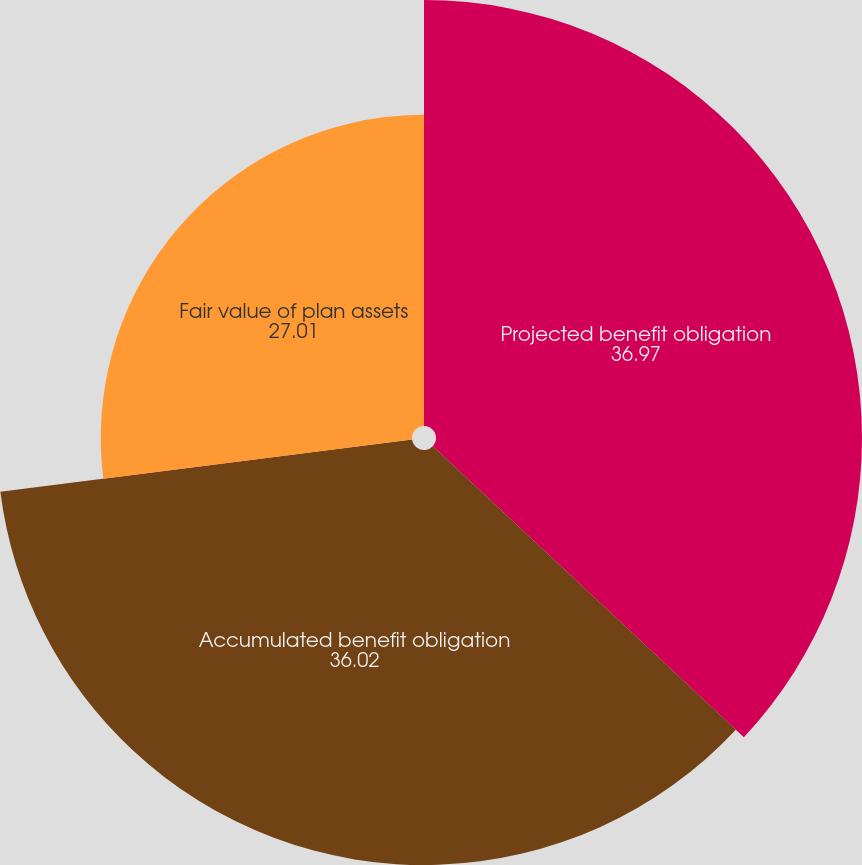<chart> <loc_0><loc_0><loc_500><loc_500><pie_chart><fcel>Projected benefit obligation<fcel>Accumulated benefit obligation<fcel>Fair value of plan assets<nl><fcel>36.97%<fcel>36.02%<fcel>27.01%<nl></chart> 